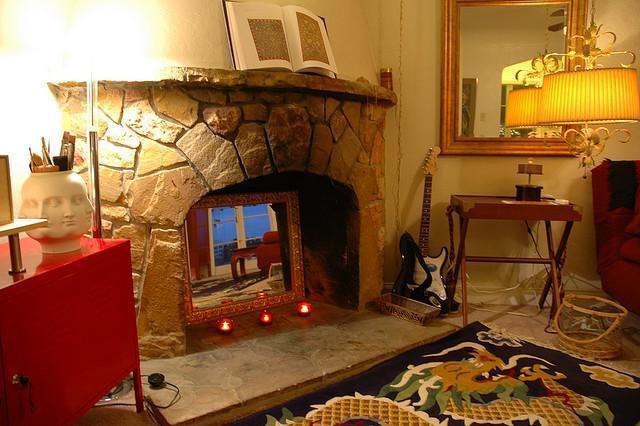How many buses are in the picture?
Give a very brief answer. 0. 